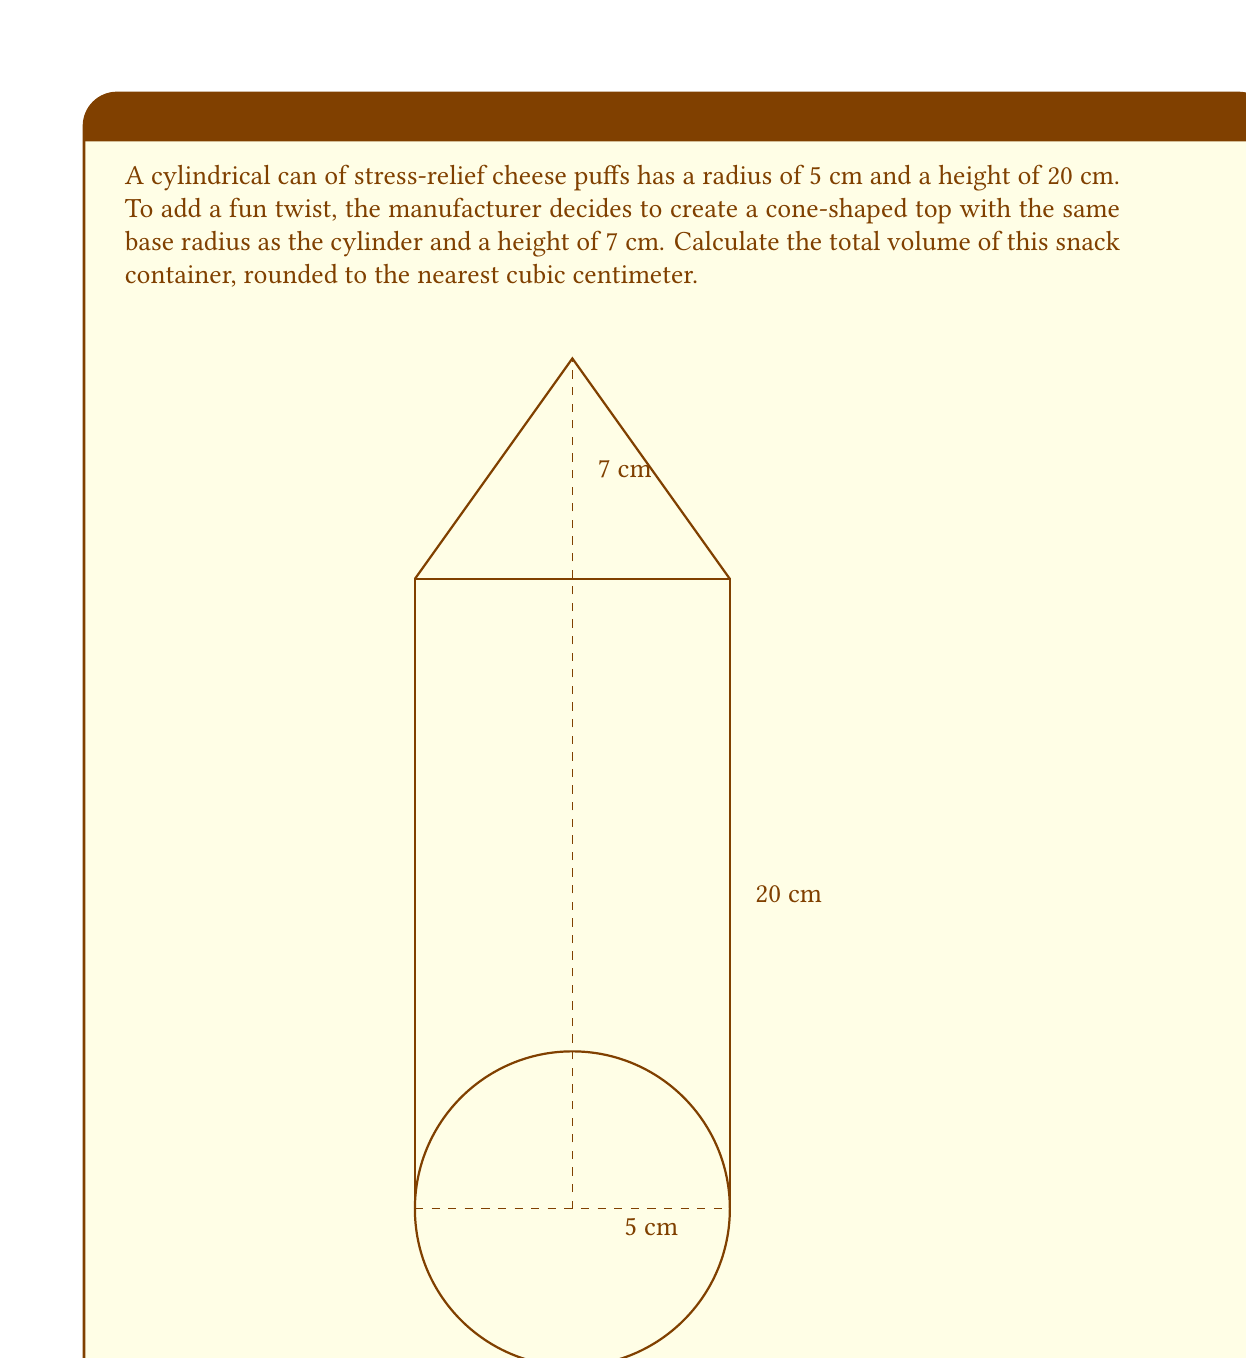Teach me how to tackle this problem. Let's approach this problem step-by-step:

1) The container consists of two parts: a cylinder and a cone. We need to calculate the volume of each and then add them together.

2) For the cylindrical part:
   Volume of a cylinder is given by the formula: $V_{cylinder} = \pi r^2 h$
   Where $r$ is the radius and $h$ is the height.
   $V_{cylinder} = \pi \cdot 5^2 \cdot 20 = 500\pi$ cm³

3) For the conical part:
   Volume of a cone is given by the formula: $V_{cone} = \frac{1}{3}\pi r^2 h$
   Where $r$ is the radius of the base and $h$ is the height of the cone.
   $V_{cone} = \frac{1}{3}\pi \cdot 5^2 \cdot 7 = \frac{175}{3}\pi$ cm³

4) Total volume:
   $V_{total} = V_{cylinder} + V_{cone}$
   $V_{total} = 500\pi + \frac{175}{3}\pi = \left(500 + \frac{175}{3}\right)\pi$ cm³
   $V_{total} = \frac{1675}{3}\pi$ cm³

5) Converting to a numerical value and rounding:
   $V_{total} \approx 1751.9$ cm³

6) Rounding to the nearest cubic centimeter:
   $V_{total} \approx 1752$ cm³
Answer: 1752 cm³ 